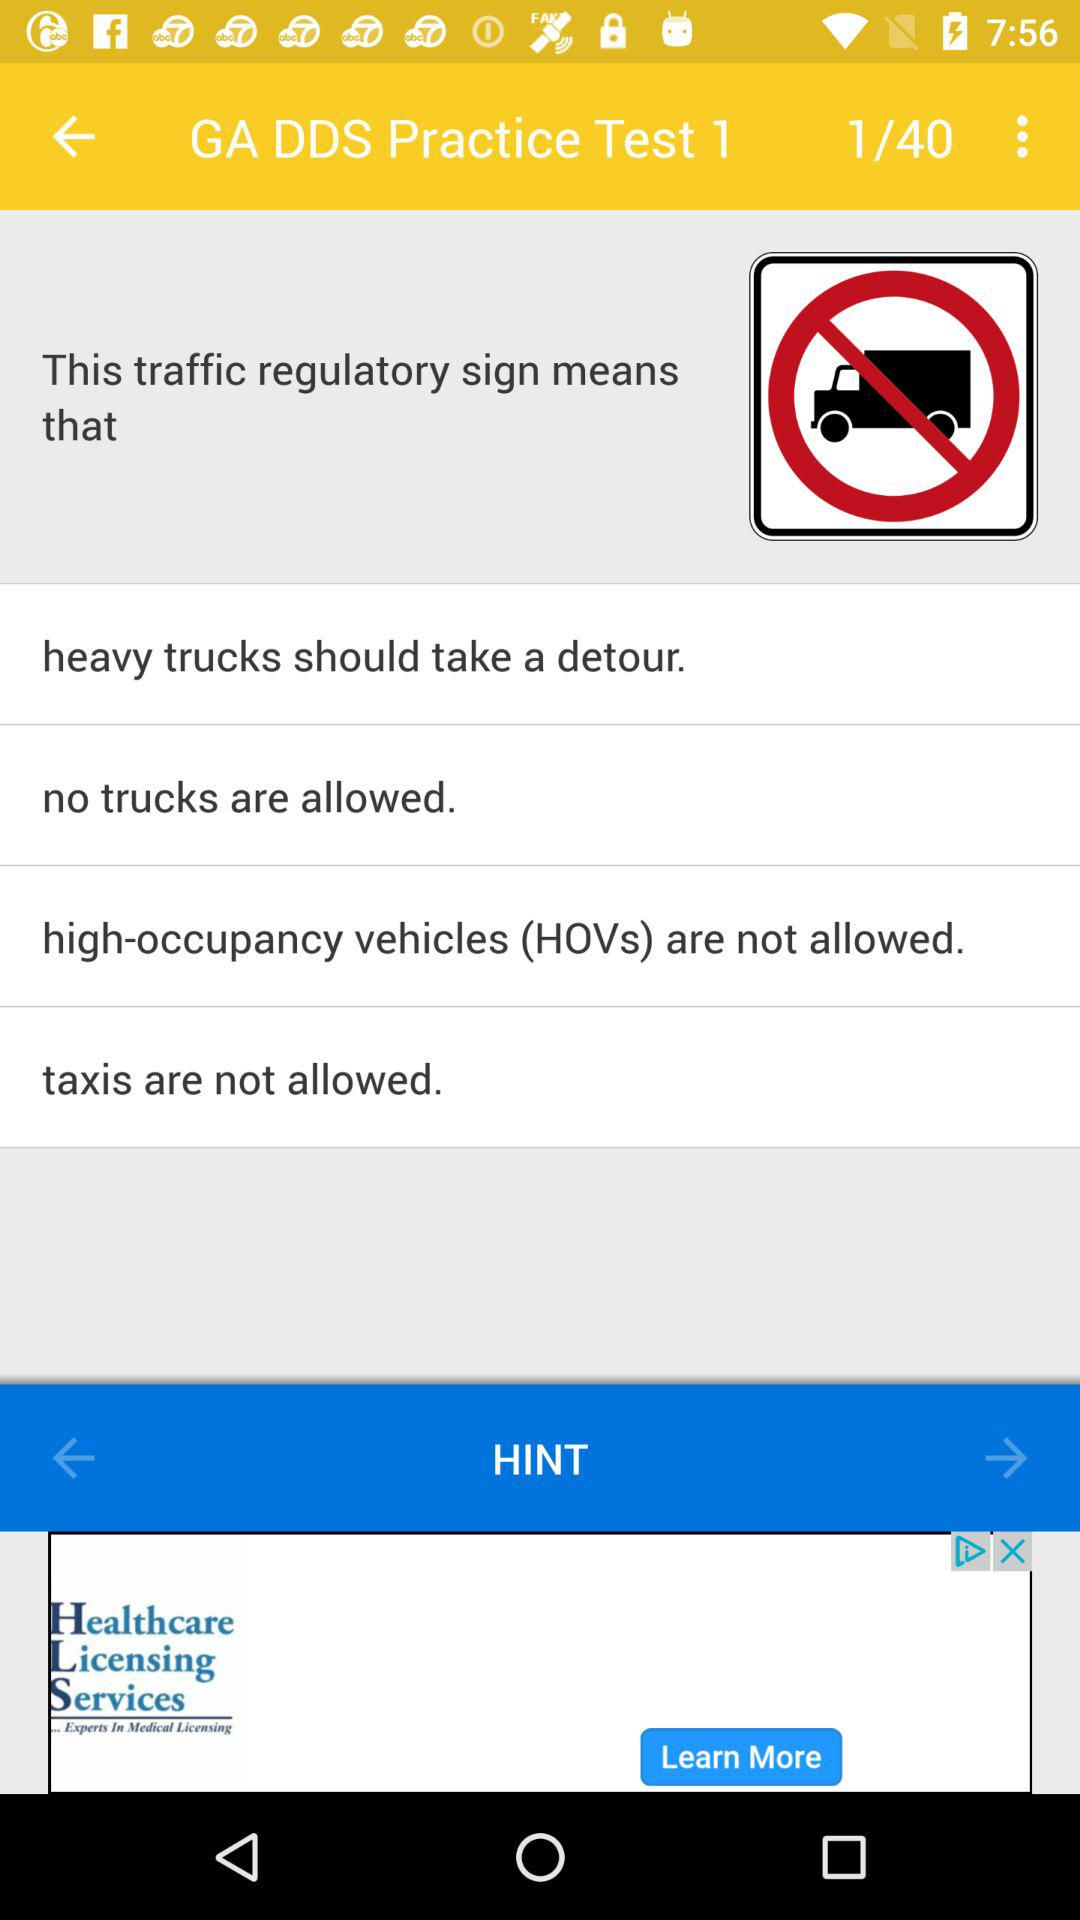How many practice sets are available? There are 40 practice sets available. 